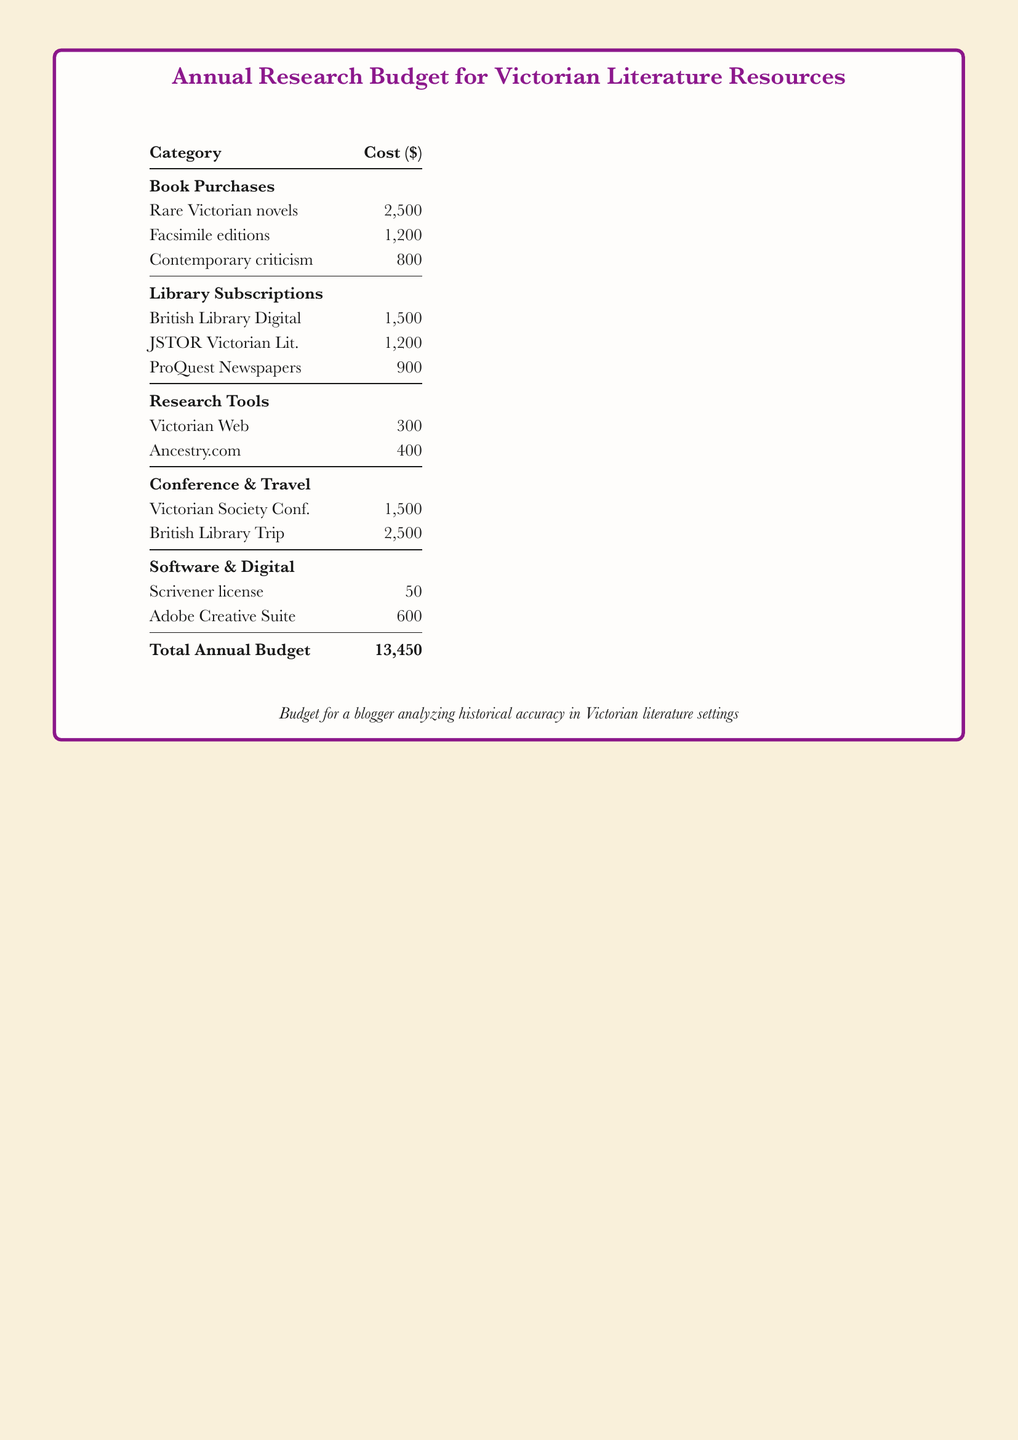What is the total annual budget? The total annual budget is the sum of all the costs listed in the document, which totals $13,450.
Answer: $13,450 How much is allocated for rare Victorian novels? The document specifies that $2,500 is allocated for rare Victorian novels under the book purchases category.
Answer: $2,500 What is the cost of the British Library trip? The cost for the British Library trip is stated as $2,500 in the conference & travel section of the budget.
Answer: $2,500 Which library subscription has the lowest cost? The lowest cost among the library subscriptions is for ProQuest Newspapers, which is $900.
Answer: ProQuest Newspapers What is the total cost of research tools? The total for research tools is $300 for Victorian Web and $400 for Ancestry.com, totaling $700.
Answer: $700 How much is set aside for software and digital resources? The document shows that $50 is allocated for Scrivener license and $600 for Adobe Creative Suite, totaling $650 for software & digital.
Answer: $650 What category has the highest total expenditure? The category with the highest total expenditure is conference & travel, with a total of $4,000.
Answer: conference & travel How much is spent on contemporary criticism? $800 is the amount allocated to contemporary criticism under the book purchases category.
Answer: $800 Which conference has a budget of $1,500? The Victorian Society Conference is specified in the document with a budget of $1,500.
Answer: Victorian Society Conf 